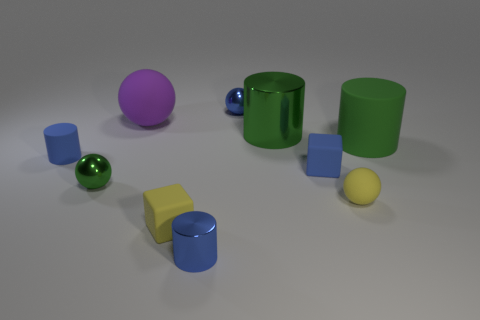Subtract all cylinders. How many objects are left? 6 Subtract 0 cyan cylinders. How many objects are left? 10 Subtract all small blue matte cylinders. Subtract all big cylinders. How many objects are left? 7 Add 3 small blue metal cylinders. How many small blue metal cylinders are left? 4 Add 9 large green shiny things. How many large green shiny things exist? 10 